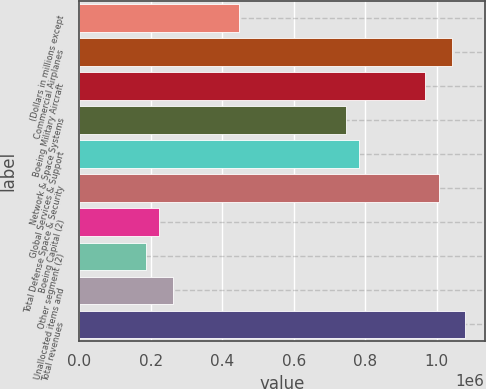Convert chart to OTSL. <chart><loc_0><loc_0><loc_500><loc_500><bar_chart><fcel>(Dollars in millions except<fcel>Commercial Airplanes<fcel>Boeing Military Aircraft<fcel>Network & Space Systems<fcel>Global Services & Support<fcel>Total Defense Space & Security<fcel>Boeing Capital (2)<fcel>Other segment (2)<fcel>Unallocated items and<fcel>Total revenues<nl><fcel>446826<fcel>1.04259e+06<fcel>968120<fcel>744708<fcel>781944<fcel>1.00536e+06<fcel>223414<fcel>186178<fcel>260649<fcel>1.07983e+06<nl></chart> 